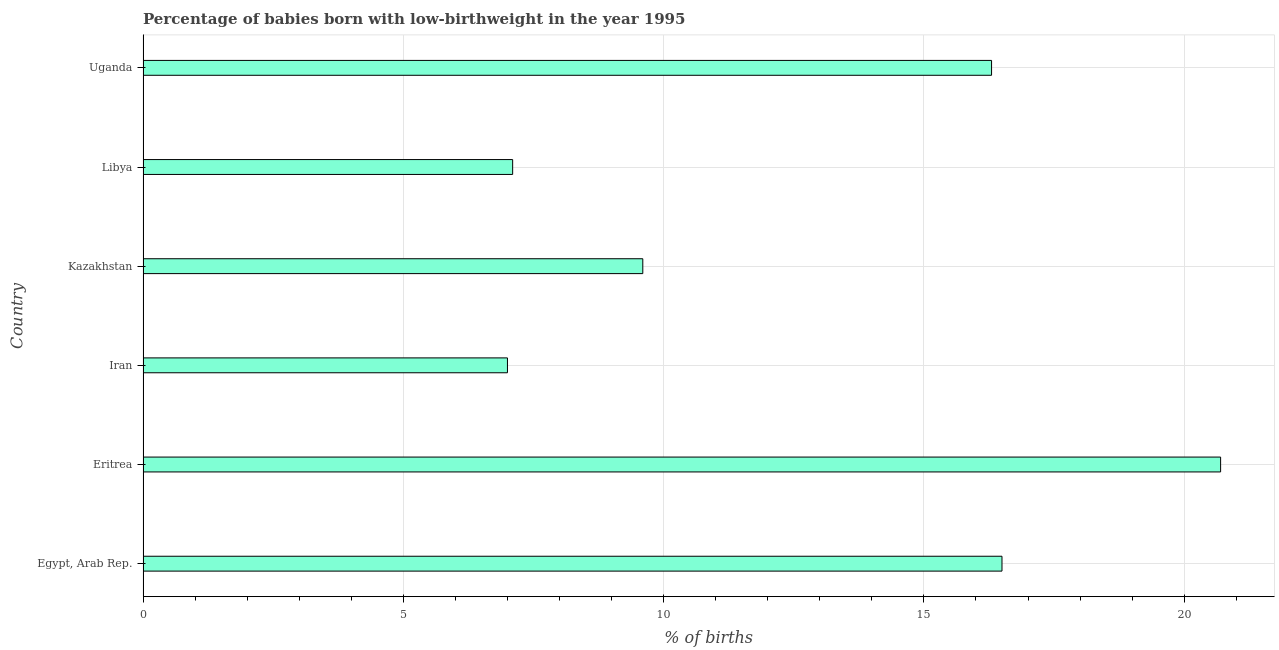Does the graph contain grids?
Give a very brief answer. Yes. What is the title of the graph?
Your response must be concise. Percentage of babies born with low-birthweight in the year 1995. What is the label or title of the X-axis?
Give a very brief answer. % of births. What is the percentage of babies who were born with low-birthweight in Eritrea?
Make the answer very short. 20.7. Across all countries, what is the maximum percentage of babies who were born with low-birthweight?
Your response must be concise. 20.7. Across all countries, what is the minimum percentage of babies who were born with low-birthweight?
Your answer should be very brief. 7. In which country was the percentage of babies who were born with low-birthweight maximum?
Your response must be concise. Eritrea. In which country was the percentage of babies who were born with low-birthweight minimum?
Provide a short and direct response. Iran. What is the sum of the percentage of babies who were born with low-birthweight?
Ensure brevity in your answer.  77.2. What is the difference between the percentage of babies who were born with low-birthweight in Egypt, Arab Rep. and Kazakhstan?
Ensure brevity in your answer.  6.9. What is the average percentage of babies who were born with low-birthweight per country?
Provide a short and direct response. 12.87. What is the median percentage of babies who were born with low-birthweight?
Keep it short and to the point. 12.95. What is the ratio of the percentage of babies who were born with low-birthweight in Libya to that in Uganda?
Give a very brief answer. 0.44. What is the difference between the highest and the second highest percentage of babies who were born with low-birthweight?
Your response must be concise. 4.2. What is the difference between the highest and the lowest percentage of babies who were born with low-birthweight?
Provide a short and direct response. 13.7. Are all the bars in the graph horizontal?
Make the answer very short. Yes. How many countries are there in the graph?
Give a very brief answer. 6. What is the difference between two consecutive major ticks on the X-axis?
Your answer should be very brief. 5. Are the values on the major ticks of X-axis written in scientific E-notation?
Your response must be concise. No. What is the % of births of Eritrea?
Your answer should be very brief. 20.7. What is the % of births of Kazakhstan?
Offer a very short reply. 9.6. What is the % of births in Libya?
Give a very brief answer. 7.1. What is the % of births of Uganda?
Ensure brevity in your answer.  16.3. What is the difference between the % of births in Egypt, Arab Rep. and Eritrea?
Offer a very short reply. -4.2. What is the difference between the % of births in Egypt, Arab Rep. and Iran?
Your answer should be compact. 9.5. What is the difference between the % of births in Egypt, Arab Rep. and Kazakhstan?
Your response must be concise. 6.9. What is the difference between the % of births in Egypt, Arab Rep. and Uganda?
Ensure brevity in your answer.  0.2. What is the difference between the % of births in Kazakhstan and Uganda?
Offer a very short reply. -6.7. What is the ratio of the % of births in Egypt, Arab Rep. to that in Eritrea?
Ensure brevity in your answer.  0.8. What is the ratio of the % of births in Egypt, Arab Rep. to that in Iran?
Give a very brief answer. 2.36. What is the ratio of the % of births in Egypt, Arab Rep. to that in Kazakhstan?
Ensure brevity in your answer.  1.72. What is the ratio of the % of births in Egypt, Arab Rep. to that in Libya?
Offer a very short reply. 2.32. What is the ratio of the % of births in Egypt, Arab Rep. to that in Uganda?
Your answer should be very brief. 1.01. What is the ratio of the % of births in Eritrea to that in Iran?
Provide a short and direct response. 2.96. What is the ratio of the % of births in Eritrea to that in Kazakhstan?
Offer a very short reply. 2.16. What is the ratio of the % of births in Eritrea to that in Libya?
Offer a very short reply. 2.92. What is the ratio of the % of births in Eritrea to that in Uganda?
Your answer should be compact. 1.27. What is the ratio of the % of births in Iran to that in Kazakhstan?
Provide a short and direct response. 0.73. What is the ratio of the % of births in Iran to that in Libya?
Give a very brief answer. 0.99. What is the ratio of the % of births in Iran to that in Uganda?
Offer a very short reply. 0.43. What is the ratio of the % of births in Kazakhstan to that in Libya?
Your answer should be compact. 1.35. What is the ratio of the % of births in Kazakhstan to that in Uganda?
Provide a short and direct response. 0.59. What is the ratio of the % of births in Libya to that in Uganda?
Keep it short and to the point. 0.44. 